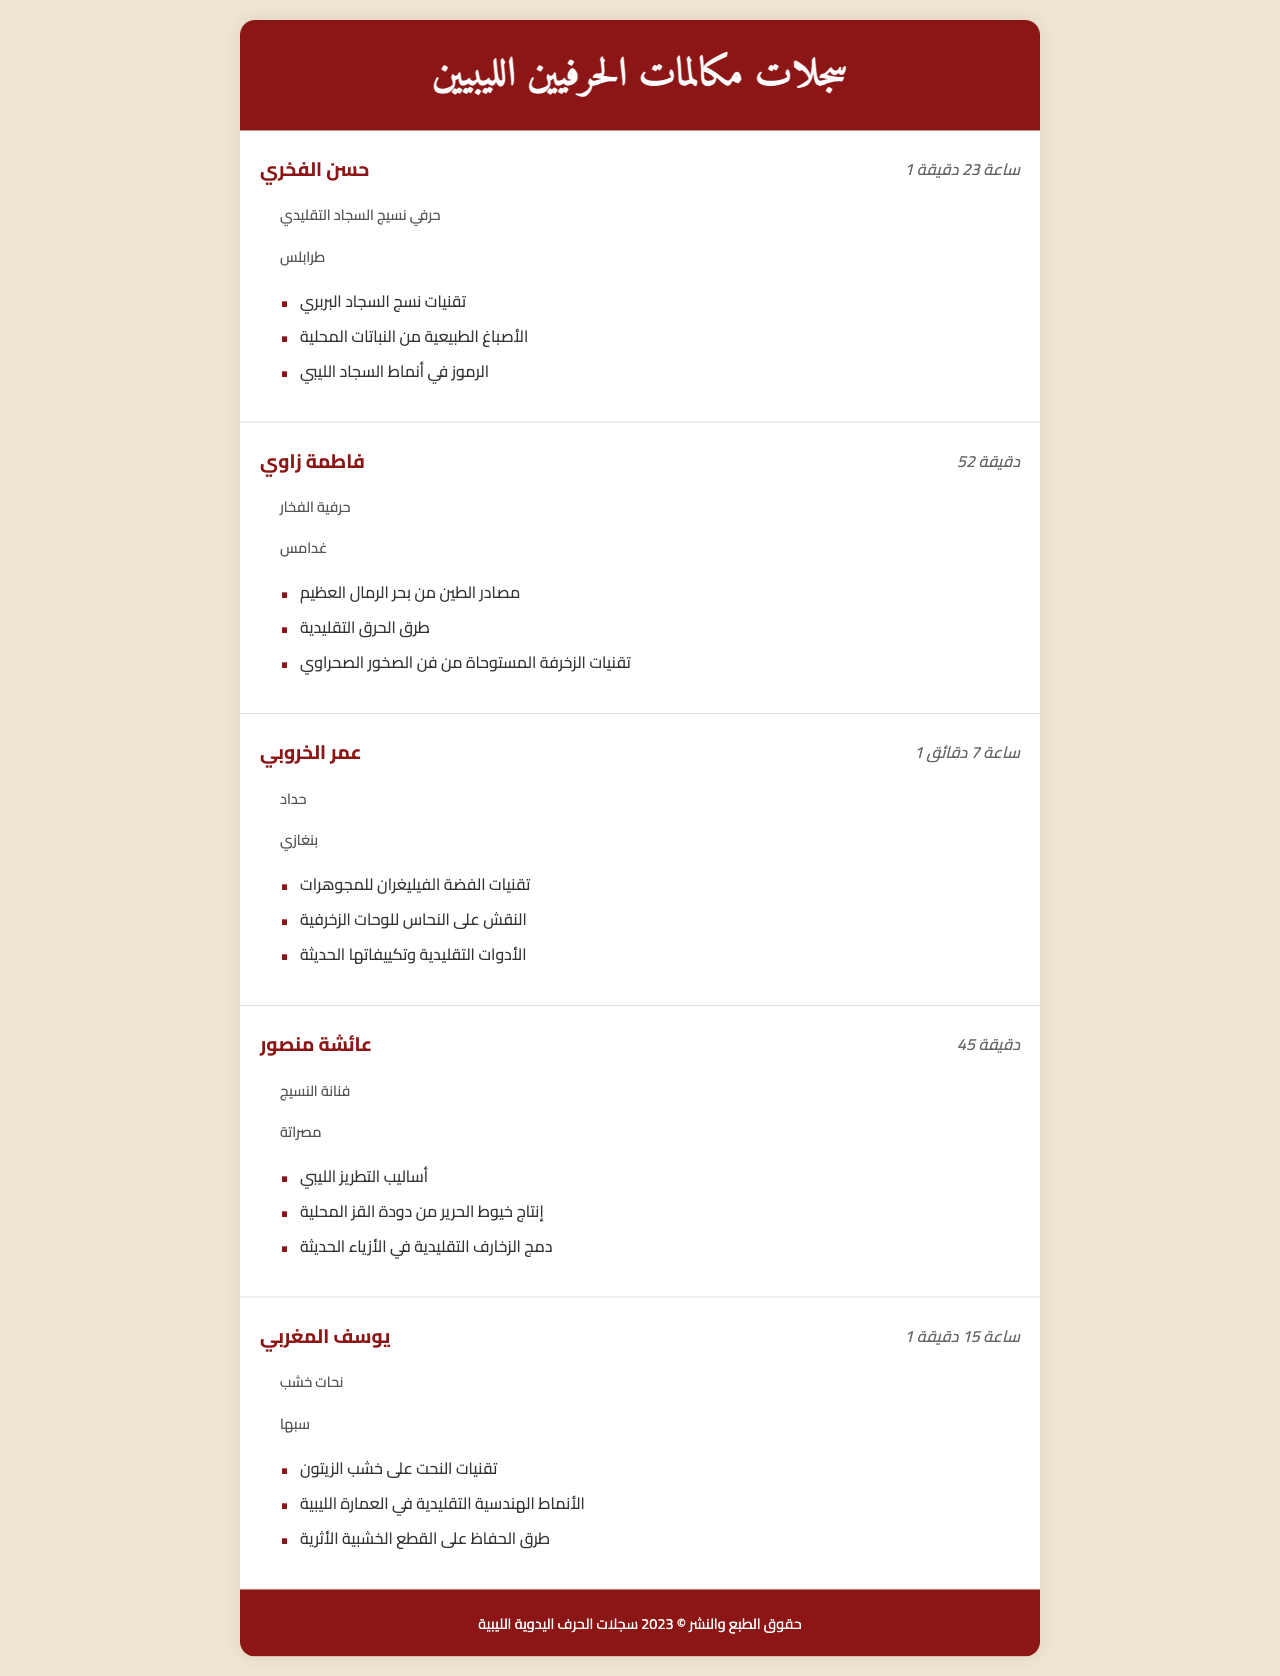what is the name of the carpet weaver? The document lists "حسن الفخري" as the name of the carpet weaver.
Answer: حسن الفخري how long did the call with the potter last? The call duration with the potter, فاطمة زاوي, is mentioned as 52 minutes.
Answer: 52 دقيقة which city does the blacksmith, عمر الخروبي, belong to? The document specifies that عمر الخروبي is from بنغازي.
Answer: بنغازي what traditional techniques were discussed by حسن الفخري? The document lists topics discussed by حسن الفخري, including traditional carpet weaving techniques.
Answer: تقنيات نسج السجاد البربري what is the occupation of عائشة منصور? "عائشة منصور" is identified as a "فنانة النسيج" or a textile artist in the document.
Answer: فنانة النسيج which artisan discussed decoration techniques inspired by desert rock art? The document shows that فاطمة زاوي discussed decoration techniques inspired by desert rock art.
Answer: فاطمة زاوي how many topics did يوسف المغربي cover in his call? The document indicates that يوسف المغربي covered three topics during his call.
Answer: 3 which type of materials did عمر الخروبي work with? The document mentions that عمر الخروبي worked with "الفضة" (silver) and "النحاس" (copper).
Answer: الفضة, النحاس where does حسن الفخري work? The document states that حسن الفخري works in طرابلس.
Answer: طرابلس 